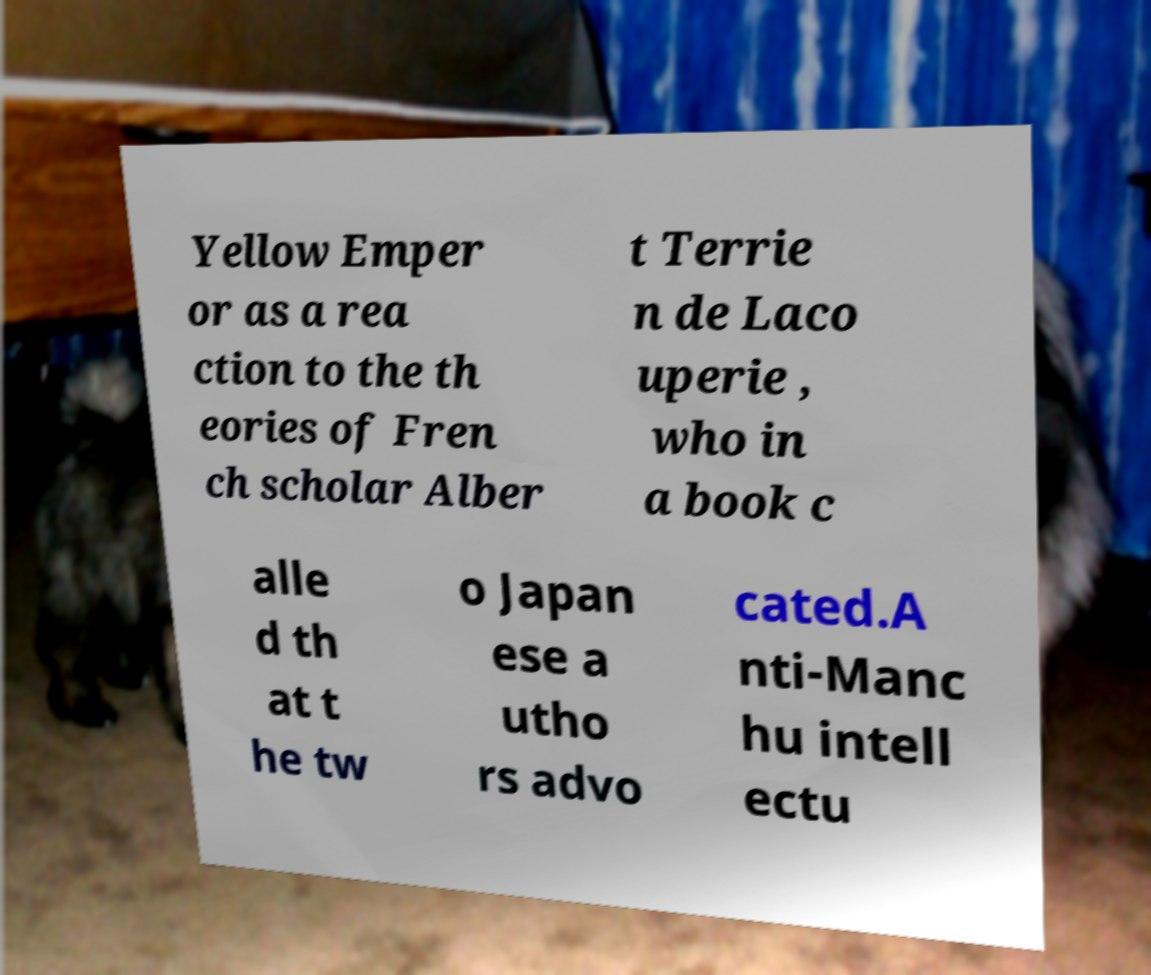Can you accurately transcribe the text from the provided image for me? Yellow Emper or as a rea ction to the th eories of Fren ch scholar Alber t Terrie n de Laco uperie , who in a book c alle d th at t he tw o Japan ese a utho rs advo cated.A nti-Manc hu intell ectu 